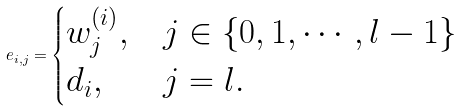<formula> <loc_0><loc_0><loc_500><loc_500>e _ { i , j } = \begin{cases} w _ { j } ^ { ( i ) } , & j \in \{ 0 , 1 , \cdots , l - 1 \} \\ d _ { i } , & j = l . \end{cases}</formula> 